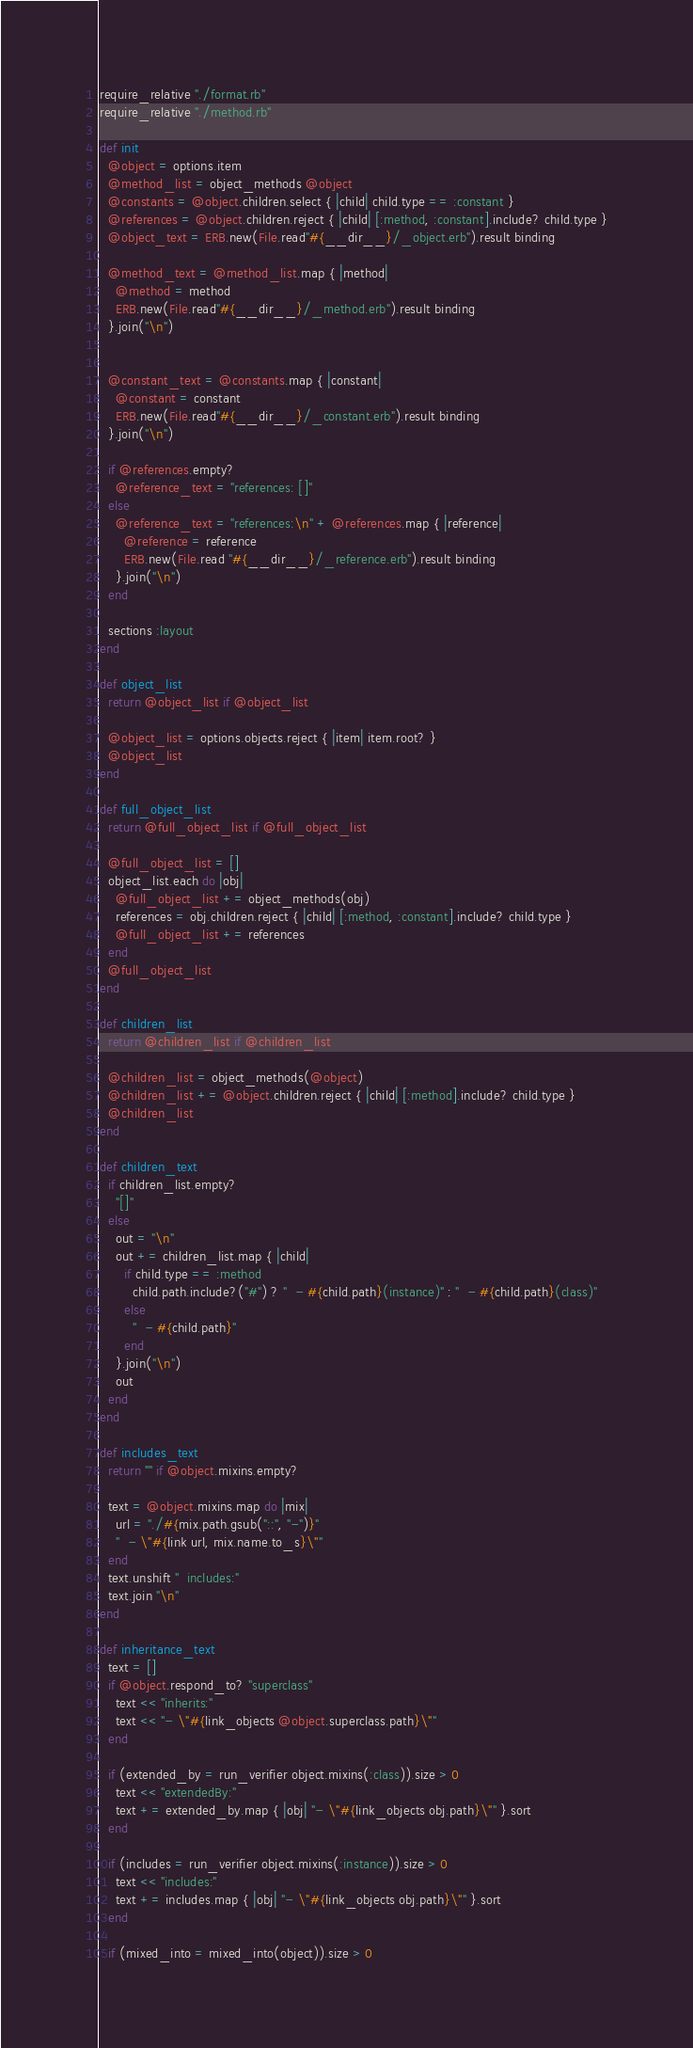Convert code to text. <code><loc_0><loc_0><loc_500><loc_500><_Ruby_>require_relative "./format.rb"
require_relative "./method.rb"

def init
  @object = options.item
  @method_list = object_methods @object
  @constants = @object.children.select { |child| child.type == :constant }
  @references = @object.children.reject { |child| [:method, :constant].include? child.type }
  @object_text = ERB.new(File.read"#{__dir__}/_object.erb").result binding

  @method_text = @method_list.map { |method|
    @method = method
    ERB.new(File.read"#{__dir__}/_method.erb").result binding
  }.join("\n")


  @constant_text = @constants.map { |constant|
    @constant = constant
    ERB.new(File.read"#{__dir__}/_constant.erb").result binding
  }.join("\n")

  if @references.empty?
    @reference_text = "references: []"
  else
    @reference_text = "references:\n" + @references.map { |reference|
      @reference = reference
      ERB.new(File.read "#{__dir__}/_reference.erb").result binding
    }.join("\n")
  end

  sections :layout
end

def object_list
  return @object_list if @object_list

  @object_list = options.objects.reject { |item| item.root? }
  @object_list
end

def full_object_list
  return @full_object_list if @full_object_list

  @full_object_list = []
  object_list.each do |obj|
    @full_object_list += object_methods(obj)
    references = obj.children.reject { |child| [:method, :constant].include? child.type }
    @full_object_list += references
  end
  @full_object_list
end

def children_list
  return @children_list if @children_list

  @children_list = object_methods(@object)
  @children_list += @object.children.reject { |child| [:method].include? child.type }
  @children_list
end

def children_text
  if children_list.empty?
    "[]"
  else
    out = "\n"
    out += children_list.map { |child|
      if child.type == :method
        child.path.include?("#") ? "  - #{child.path}(instance)" : "  - #{child.path}(class)"
      else
        "  - #{child.path}"
      end
    }.join("\n")
    out
  end
end

def includes_text
  return "" if @object.mixins.empty?

  text = @object.mixins.map do |mix| 
    url = "./#{mix.path.gsub("::", "-")}"
    "  - \"#{link url, mix.name.to_s}\""
  end
  text.unshift "  includes:"
  text.join "\n"
end

def inheritance_text
  text = []
  if @object.respond_to? "superclass"
    text << "inherits:"
    text << "- \"#{link_objects @object.superclass.path}\""
  end
  
  if (extended_by = run_verifier object.mixins(:class)).size > 0
    text << "extendedBy:"
    text += extended_by.map { |obj| "- \"#{link_objects obj.path}\"" }.sort
  end

  if (includes = run_verifier object.mixins(:instance)).size > 0
    text << "includes:"
    text += includes.map { |obj| "- \"#{link_objects obj.path}\"" }.sort
  end

  if (mixed_into = mixed_into(object)).size > 0</code> 